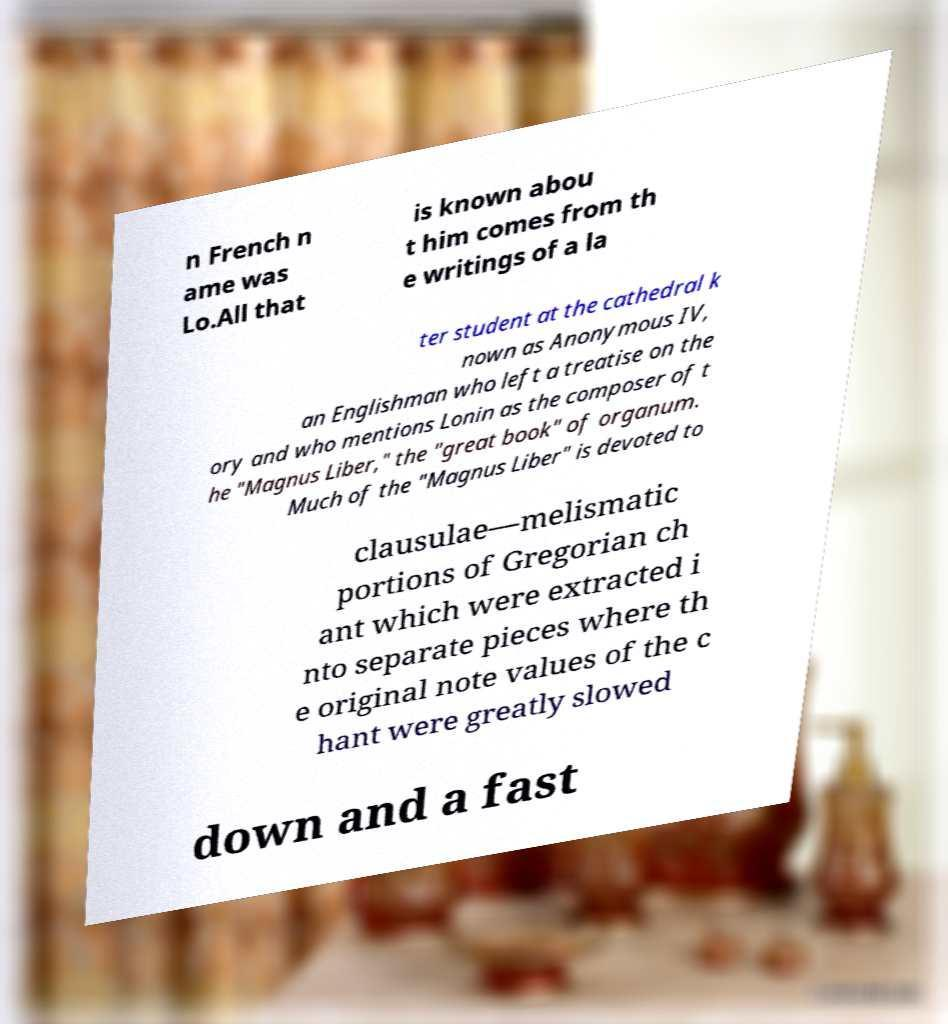Can you accurately transcribe the text from the provided image for me? n French n ame was Lo.All that is known abou t him comes from th e writings of a la ter student at the cathedral k nown as Anonymous IV, an Englishman who left a treatise on the ory and who mentions Lonin as the composer of t he "Magnus Liber," the "great book" of organum. Much of the "Magnus Liber" is devoted to clausulae—melismatic portions of Gregorian ch ant which were extracted i nto separate pieces where th e original note values of the c hant were greatly slowed down and a fast 